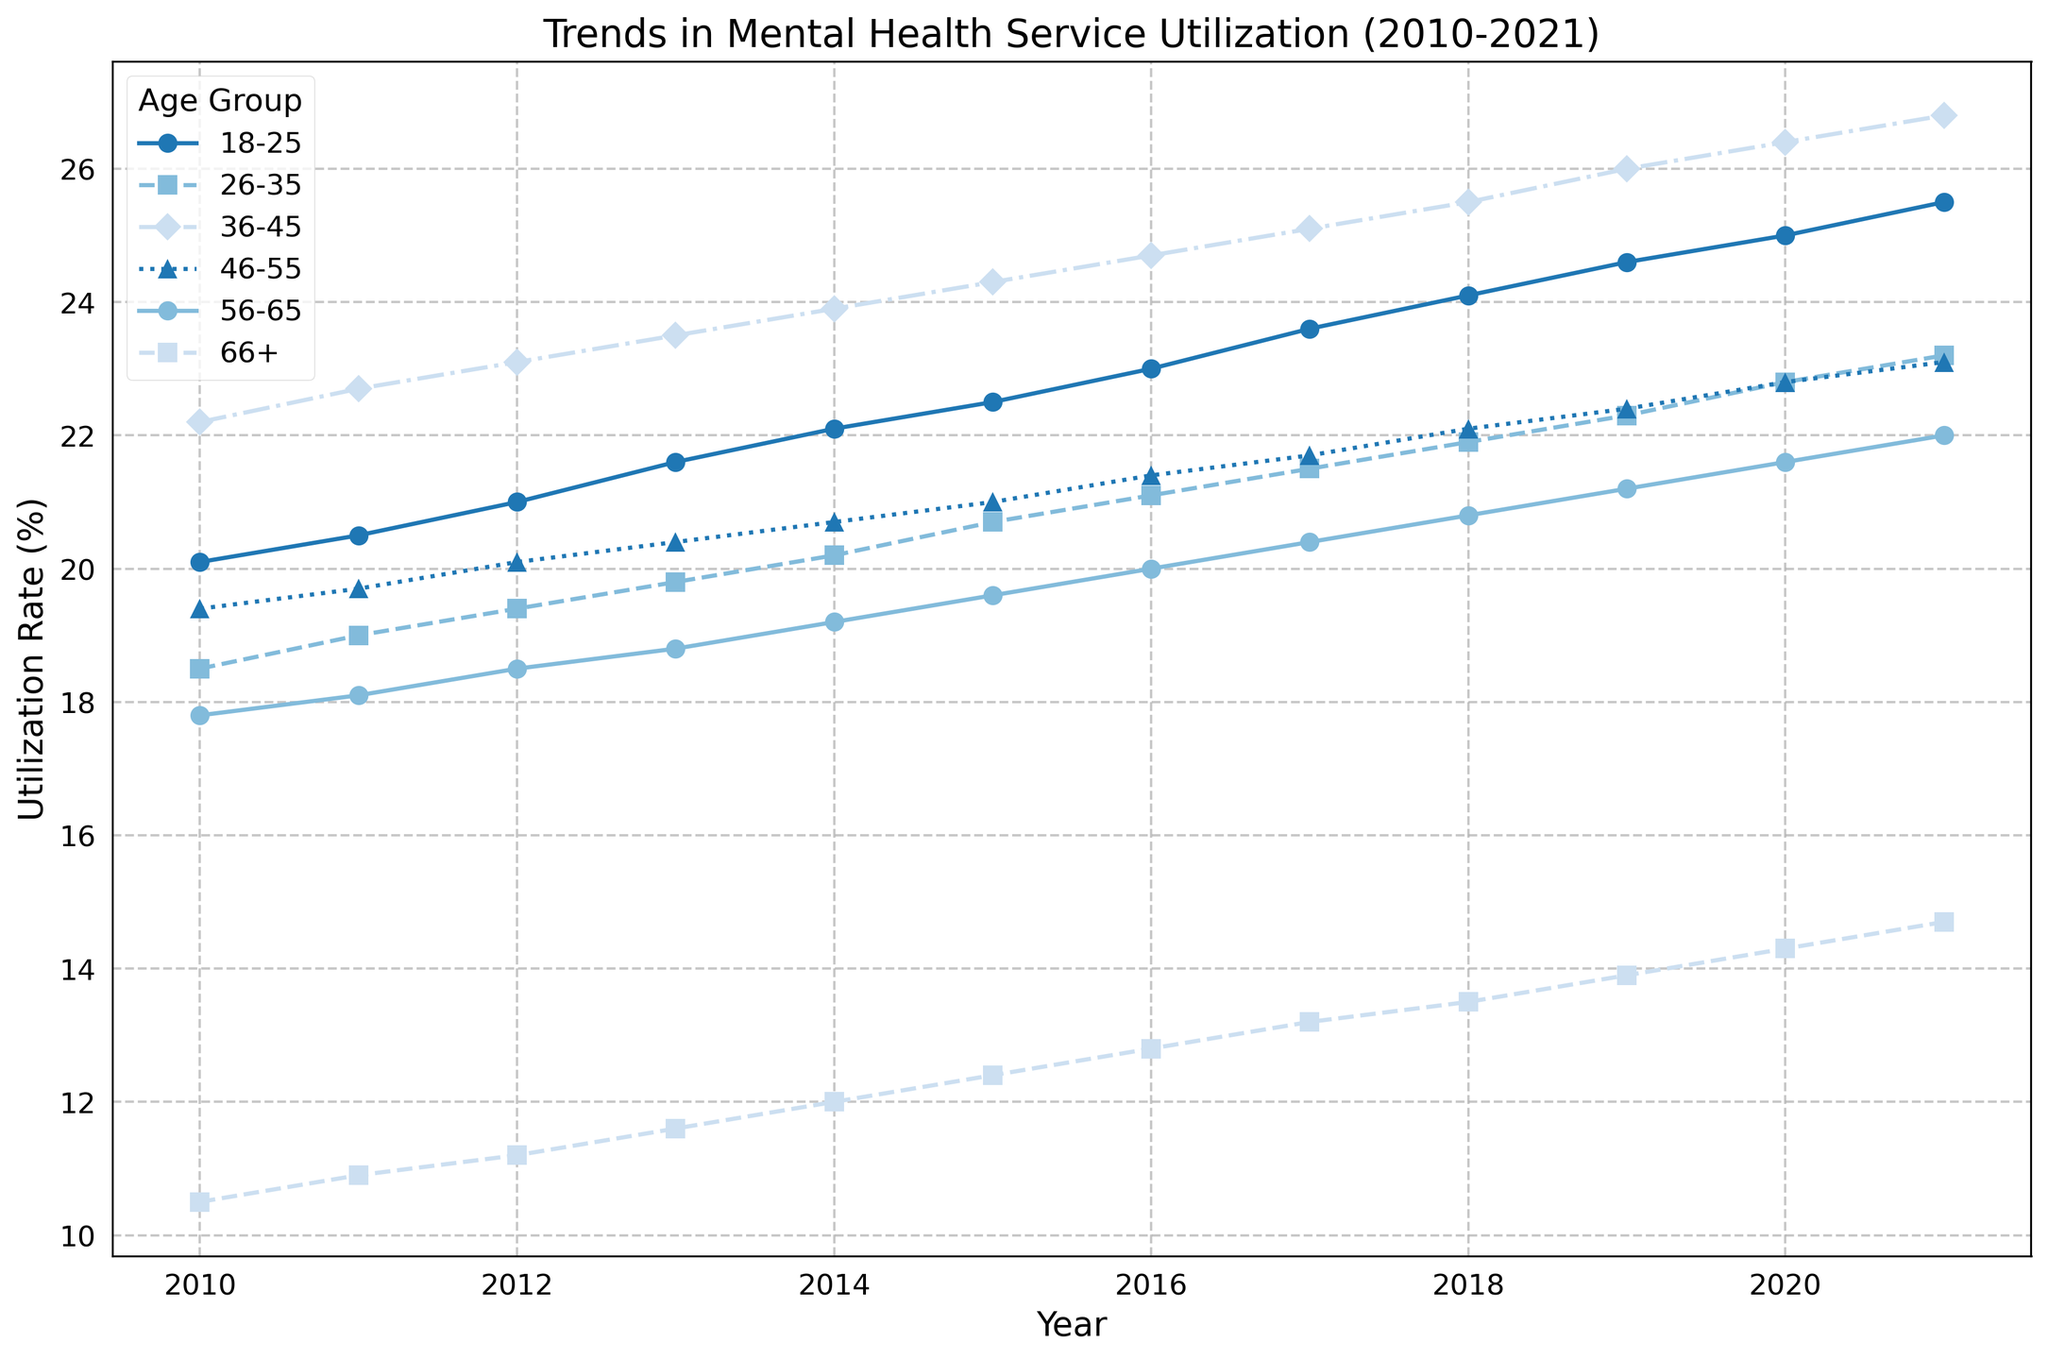Which age group sees the steepest increase in utilization over the decade? The age group with the steepest increase can be identified by looking at the slopes of the lines in the chart. The 18-25 age group's utilization rate increased from 20.1% in 2010 to 25.5% in 2021, which is the steepest among all groups.
Answer: 18-25 How did the utilization rate for the 66+ age group change over the years? Start by looking at the point for 2010, which is 10.5%, and then observe the change each year until 2021, which is 14.7%. This shows a gradual increase over the years.
Answer: Gradual increase Which two age groups had a crossing point where their utilization rates were equal or close to equal? Look for points where two lines cross or come very close to each other. The lines for age groups 46-55 and 56-65 nearly cross each other around 2011-2012.
Answer: 46-55 and 56-65 Which year saw the highest overall utilization rate across all age groups? Scan the peaks for each year, and you will notice 2021 has the highest peaks across most age groups, indicating the highest overall utilization rate.
Answer: 2021 What is the average utilization rate for the 26-35 age group over the decade? Sum the utilization rates for each year from 2010 to 2021 and divide by the number of years (12). (18.5 + 19.0 + 19.4 + 19.8 + 20.2 + 20.7 + 21.1 + 21.5 + 21.9 + 22.3 + 22.8 + 23.2) / 12 = 20.775
Answer: 20.775 Which age group consistently shows the lowest utilization rate? By observing the chart, the age group 66+ consistently has the lowest utilization rates across all years.
Answer: 66+ By how much did the utilization rate for the 36-45 age group change from 2010 to 2021? Subtract the 2010 rate from the 2021 rate for 36-45. The values are 26.8% in 2021 and 22.2% in 2010. The difference is 26.8% - 22.2% = 4.6%.
Answer: 4.6% What is the trend in utilization rate for the 18-25 age group? Observe the line for the 18-25 age group; it shows a consistent upward trend from 20.1% in 2010 to 25.5% in 2021.
Answer: Upward trend Which age group had the smallest increase in utilization rate over the decade? Calculate the change from 2010 to 2021 for all age groups. The 46-55 age group increased only from 19.4% to 23.1%, which is an increase of 3.7%, the smallest among all groups.
Answer: 46-55 